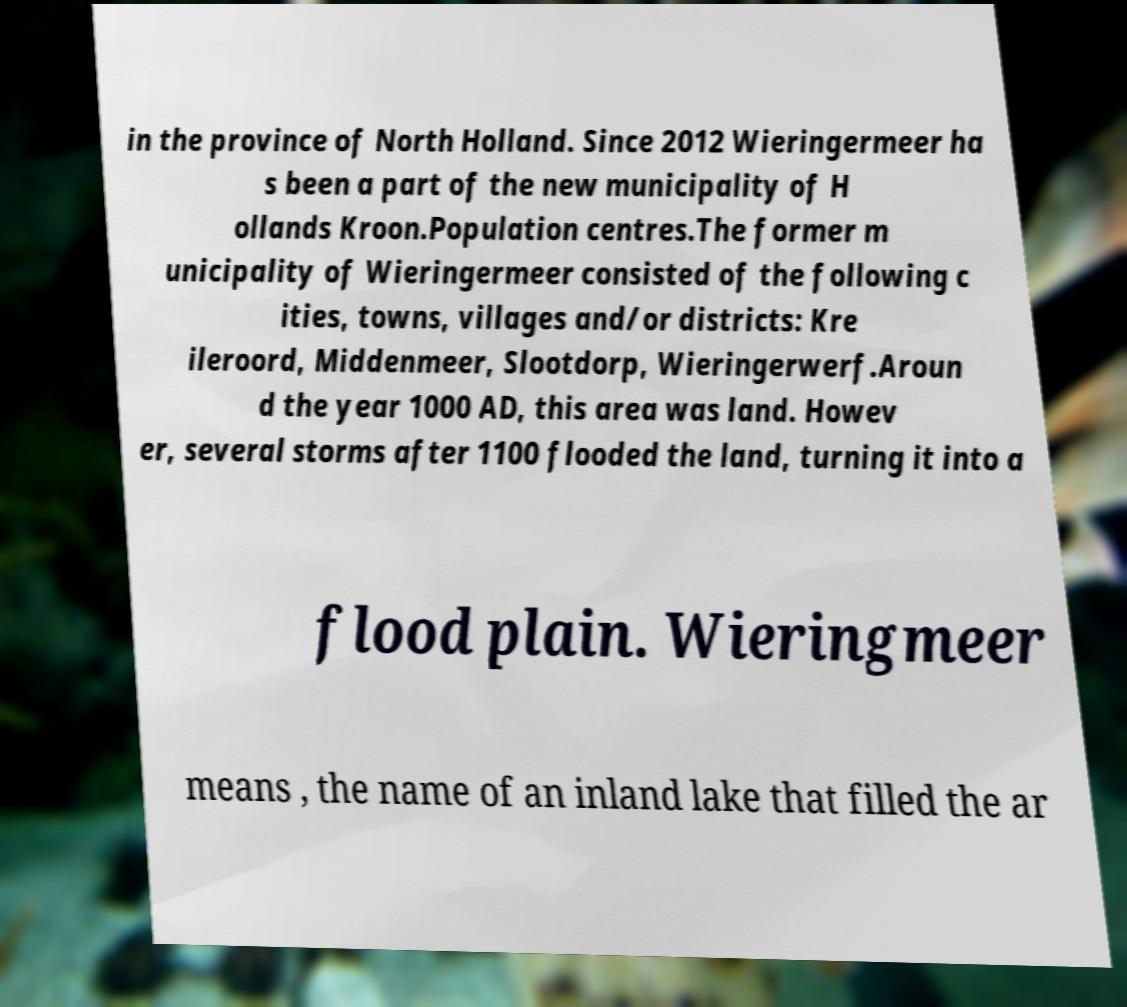Can you accurately transcribe the text from the provided image for me? in the province of North Holland. Since 2012 Wieringermeer ha s been a part of the new municipality of H ollands Kroon.Population centres.The former m unicipality of Wieringermeer consisted of the following c ities, towns, villages and/or districts: Kre ileroord, Middenmeer, Slootdorp, Wieringerwerf.Aroun d the year 1000 AD, this area was land. Howev er, several storms after 1100 flooded the land, turning it into a flood plain. Wieringmeer means , the name of an inland lake that filled the ar 